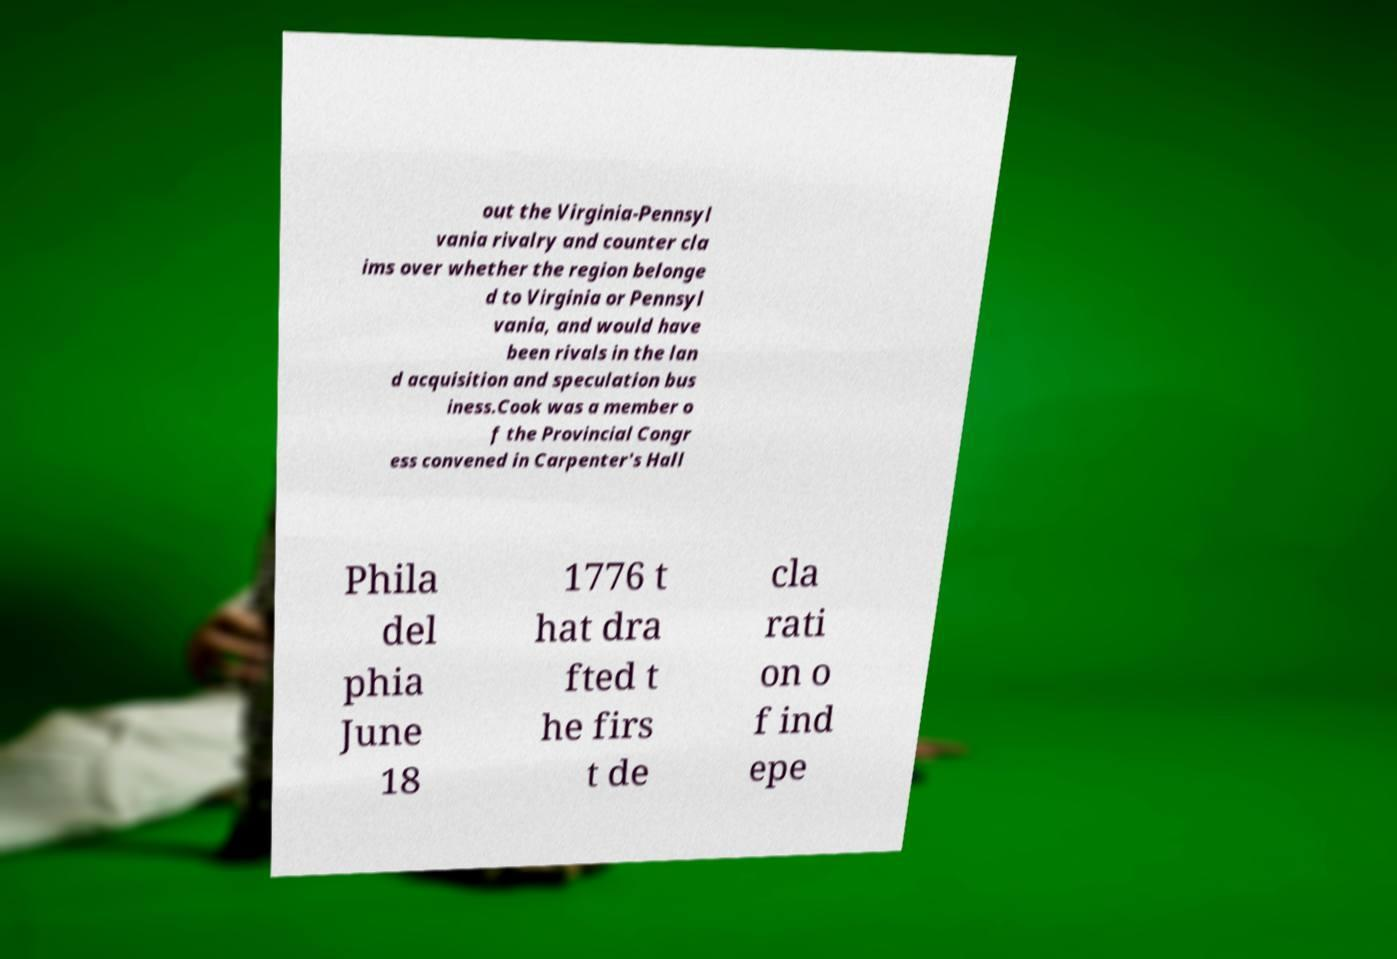I need the written content from this picture converted into text. Can you do that? out the Virginia-Pennsyl vania rivalry and counter cla ims over whether the region belonge d to Virginia or Pennsyl vania, and would have been rivals in the lan d acquisition and speculation bus iness.Cook was a member o f the Provincial Congr ess convened in Carpenter's Hall Phila del phia June 18 1776 t hat dra fted t he firs t de cla rati on o f ind epe 